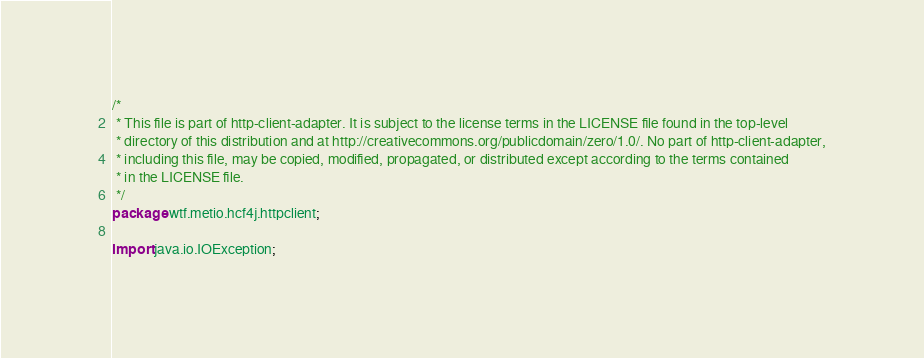<code> <loc_0><loc_0><loc_500><loc_500><_Java_>/*
 * This file is part of http-client-adapter. It is subject to the license terms in the LICENSE file found in the top-level
 * directory of this distribution and at http://creativecommons.org/publicdomain/zero/1.0/. No part of http-client-adapter,
 * including this file, may be copied, modified, propagated, or distributed except according to the terms contained
 * in the LICENSE file.
 */
package wtf.metio.hcf4j.httpclient;

import java.io.IOException;</code> 